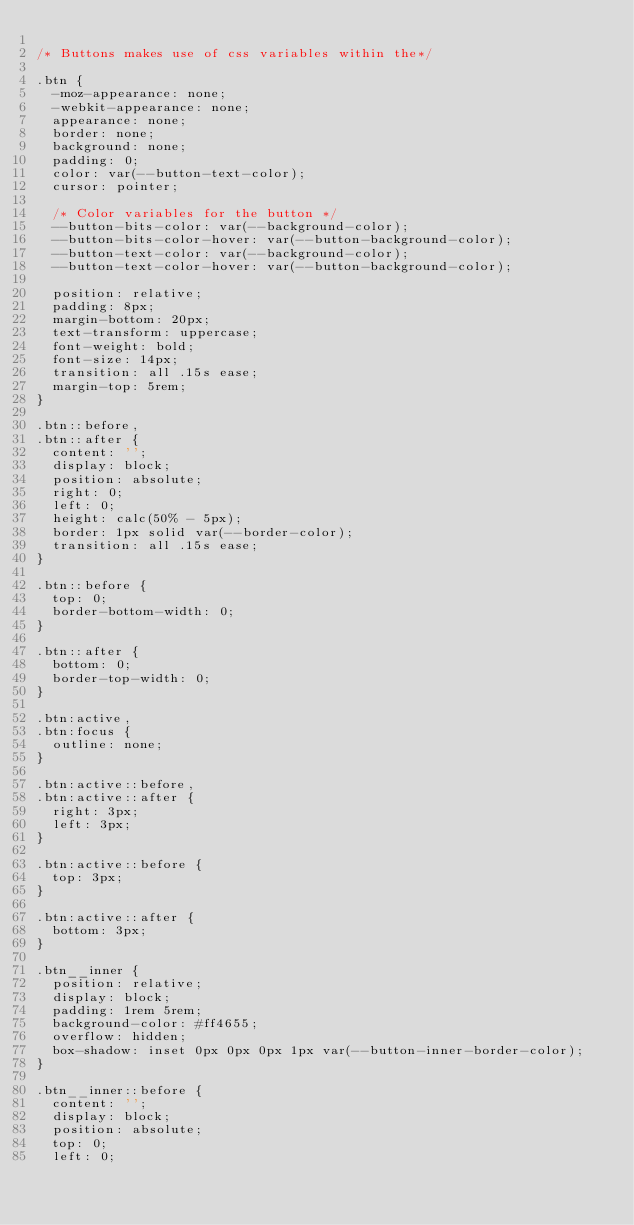<code> <loc_0><loc_0><loc_500><loc_500><_CSS_>
/* Buttons makes use of css variables within the*/

.btn {
  -moz-appearance: none;
  -webkit-appearance: none;
  appearance: none;
  border: none;
  background: none;
  padding: 0;
  color: var(--button-text-color);
  cursor: pointer;

  /* Color variables for the button */
  --button-bits-color: var(--background-color);
  --button-bits-color-hover: var(--button-background-color);
  --button-text-color: var(--background-color);
  --button-text-color-hover: var(--button-background-color);

  position: relative;
  padding: 8px;
  margin-bottom: 20px;
  text-transform: uppercase;
  font-weight: bold;
  font-size: 14px;
  transition: all .15s ease;
  margin-top: 5rem;
}

.btn::before,
.btn::after {
  content: '';
  display: block;
  position: absolute;
  right: 0;
  left: 0;
  height: calc(50% - 5px);
  border: 1px solid var(--border-color);
  transition: all .15s ease;
}

.btn::before {
  top: 0;
  border-bottom-width: 0;
}

.btn::after {
  bottom: 0;
  border-top-width: 0;
}

.btn:active,
.btn:focus {
  outline: none;
}

.btn:active::before,
.btn:active::after {
  right: 3px;
  left: 3px;
}

.btn:active::before {
  top: 3px;
}

.btn:active::after {
  bottom: 3px;
}

.btn__inner {
  position: relative;
  display: block;
  padding: 1rem 5rem;
  background-color: #ff4655;
  overflow: hidden;
  box-shadow: inset 0px 0px 0px 1px var(--button-inner-border-color);
}

.btn__inner::before {
  content: '';
  display: block;
  position: absolute;
  top: 0;
  left: 0;</code> 